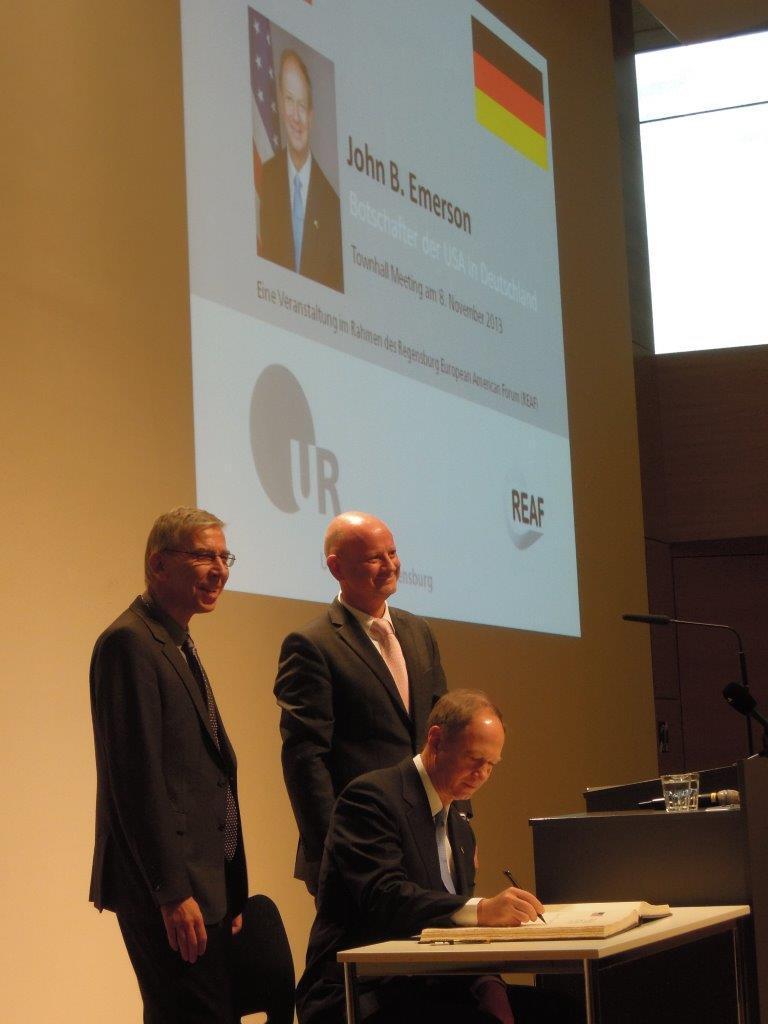Could you give a brief overview of what you see in this image? In this picture there are two people who are standing and a guy who is signing a document. All these guys are wearing black coats. In the background we observe a screen representing JOHN B HAMMERSON. To the right side of the image there is a brown table with mic on top of it. There is a window to the right side of the image. 